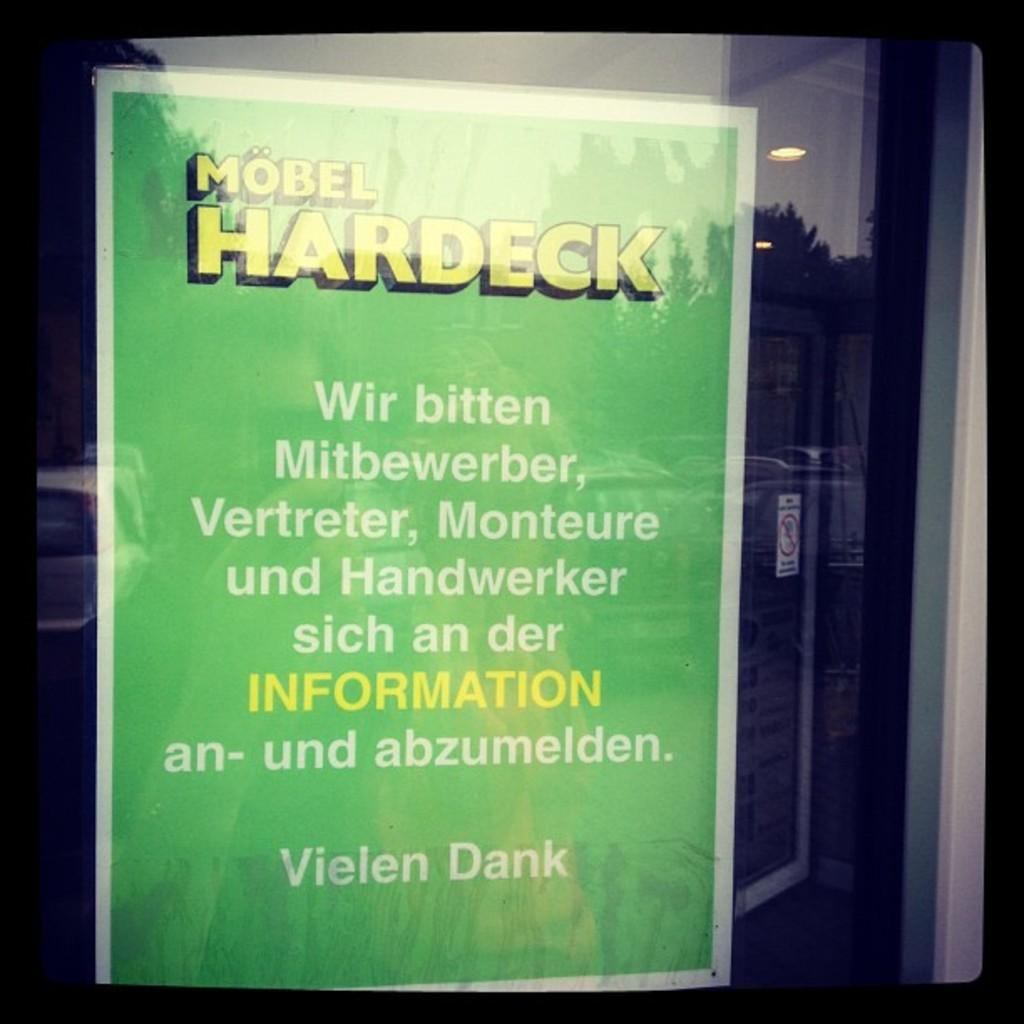<image>
Relay a brief, clear account of the picture shown. The green sign in the windown starts with the words Mobel Hardeck. 